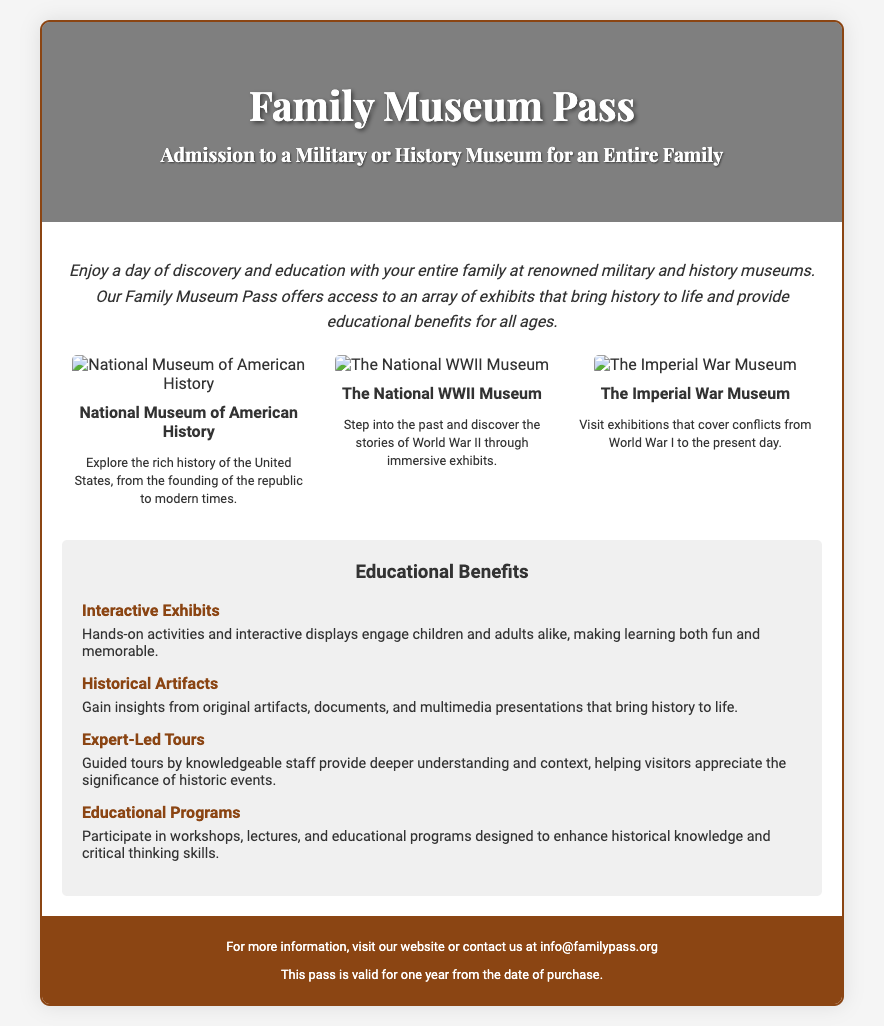What is the title of the voucher? The title of the voucher can be found in the header section of the document, which states "Family Museum Pass."
Answer: Family Museum Pass What type of museum does the pass provide admission to? The document specifies that the pass provides admission to either a military or history museum.
Answer: Military or history museum How many museums are highlighted in the document? The content mentions three specific museums in the "museums" section.
Answer: Three What museum showcases the rich history of the United States? The specific museum that explores the rich history of the US is mentioned in the section describing the museums.
Answer: National Museum of American History What are the educational benefits mentioned in the document? The document lists several benefits, with "Interactive Exhibits" being the first item under "Educational Benefits."
Answer: Interactive Exhibits Which museum focuses on World War II? The museum associated with World War II is explicitly identified in the section that describes the museums.
Answer: The National WWII Museum What is the validity period of the pass? The footer of the document provides information about the duration for which the pass is valid, which is one year.
Answer: One year What kind of programs can families participate in according to the benefits section? The document explains that families can participate in "Educational Programs," which are detailed under benefits.
Answer: Educational Programs 